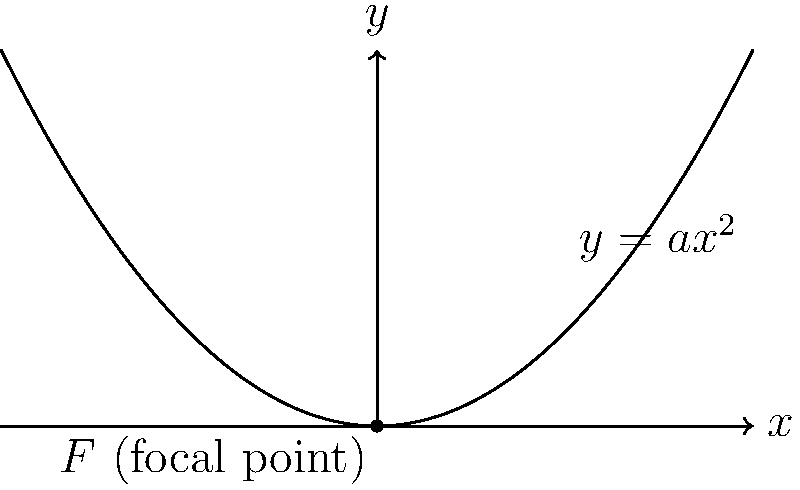In optimizing a parabolic antenna for a home network setup, you need to determine the focal length of the antenna to maximize signal strength. Given that the parabolic curve of the antenna is described by the equation $y = ax^2$, where $a$ is a positive constant, and the focal point $F$ is located at the origin $(0,0)$, what is the relationship between the focal length $f$ and the constant $a$? To determine the relationship between the focal length $f$ and the constant $a$, we'll follow these steps:

1) The general equation of a parabola with vertex at the origin and axis of symmetry along the y-axis is:

   $y = ax^2$

2) For a parabola with this form, the focal length $f$ is related to the constant $a$ by the formula:

   $f = \frac{1}{4a}$

3) This relationship can be derived from the properties of parabolas:
   - The distance from any point on the parabola to the focal point is equal to the distance from that point to the directrix.
   - The directrix is a horizontal line with equation $y = -\frac{1}{4a}$

4) The focal length $f$ is the distance from the vertex (0,0) to the focal point $F$, which is equal to the distance from the vertex to the directrix.

5) Therefore, we can conclude that:

   $f = \frac{1}{4a}$

This relationship is crucial for optimizing the parabolic antenna. A smaller value of $a$ results in a larger focal length, which means a "shallower" parabola. Conversely, a larger value of $a$ results in a smaller focal length and a "deeper" parabola.

In the context of home network setups, the optimal value of $a$ (and consequently, $f$) would depend on factors such as the frequency of the Wi-Fi signal, the size of the area to be covered, and the position of the antenna relative to the router or access point.
Answer: $f = \frac{1}{4a}$ 